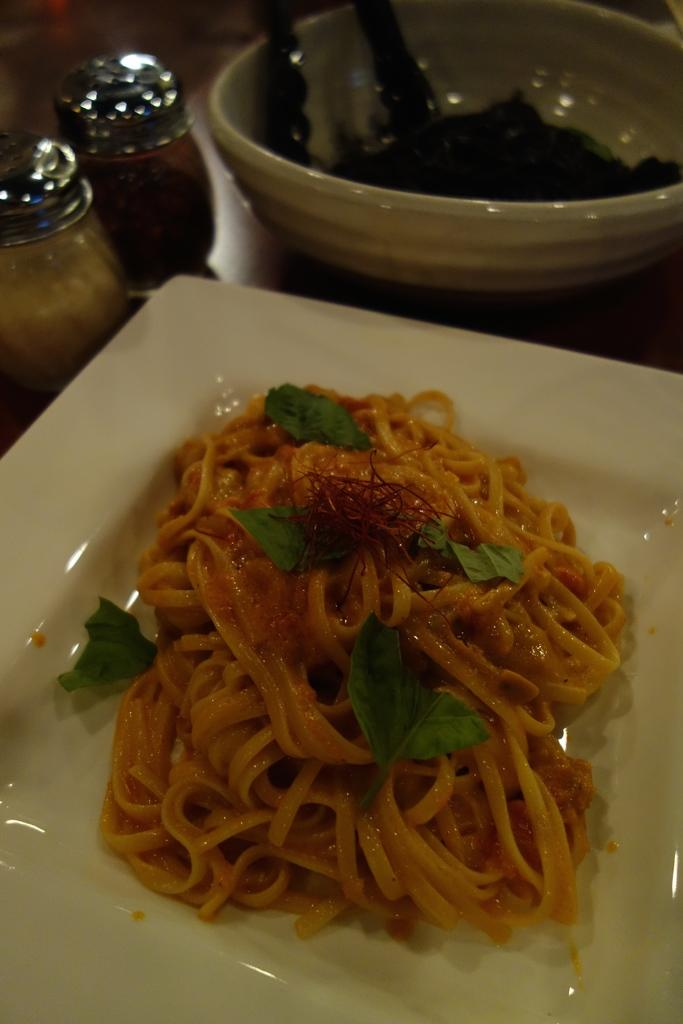What type of food is in the plate in the image? The facts do not specify the type of food in the plate. What type of food is in the bowl in the image? The facts do not specify the type of food in the bowl. What condiments are present on the table in the image? Salt and pepper shakers are present on the table in the image. How many oranges are visible in the image? There are no oranges present in the image. Is there a notebook on the table in the image? There is no mention of a notebook in the image. 